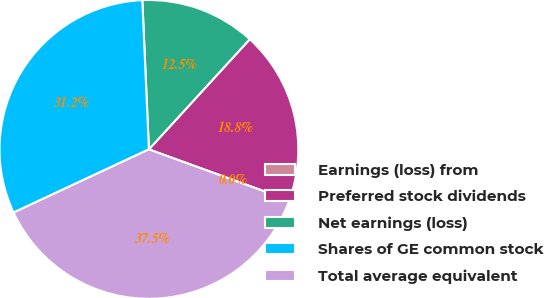<chart> <loc_0><loc_0><loc_500><loc_500><pie_chart><fcel>Earnings (loss) from<fcel>Preferred stock dividends<fcel>Net earnings (loss)<fcel>Shares of GE common stock<fcel>Total average equivalent<nl><fcel>0.0%<fcel>18.75%<fcel>12.5%<fcel>31.25%<fcel>37.5%<nl></chart> 